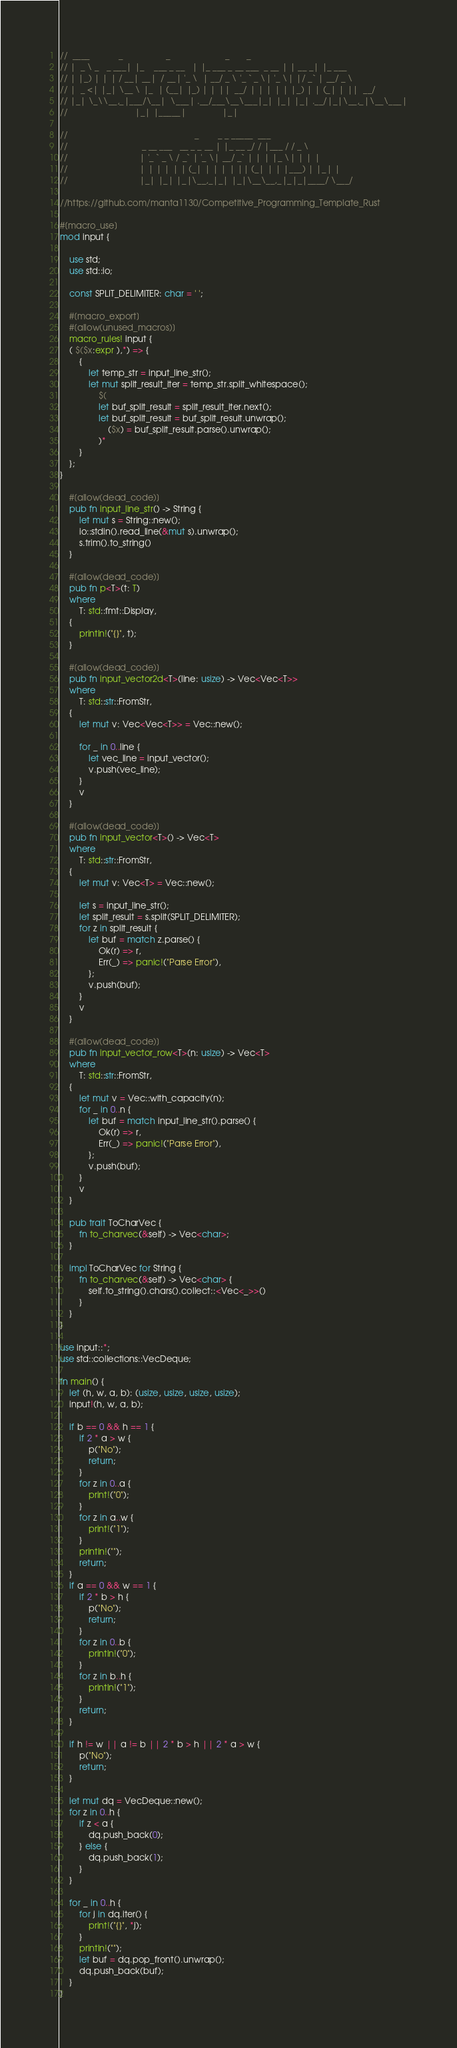<code> <loc_0><loc_0><loc_500><loc_500><_Rust_>//  ____            _                  _                       _       _
// |  _ \ _   _ ___| |_    ___ _ __   | |_ ___ _ __ ___  _ __ | | __ _| |_ ___
// | |_) | | | / __| __|  / __| '_ \  | __/ _ \ '_ ` _ \| '_ \| |/ _` | __/ _ \
// |  _ <| |_| \__ \ |_  | (__| |_) | | ||  __/ | | | | | |_) | | (_| | ||  __/
// |_| \_\\__,_|___/\__|  \___| .__/___\__\___|_| |_| |_| .__/|_|\__,_|\__\___|
//                            |_| |_____|               |_|

//                                                     _        _ _ _____  ___
//                               _ __ ___   __ _ _ __ | |_ __ _/ / |___ / / _ \
//                              | '_ ` _ \ / _` | '_ \| __/ _` | | | |_ \| | | |
//                              | | | | | | (_| | | | | || (_| | | |___) | |_| |
//                              |_| |_| |_|\__,_|_| |_|\__\__,_|_|_|____/ \___/

//https://github.com/manta1130/Competitive_Programming_Template_Rust

#[macro_use]
mod input {

    use std;
    use std::io;

    const SPLIT_DELIMITER: char = ' ';

    #[macro_export]
    #[allow(unused_macros)]
    macro_rules! input {
    ( $($x:expr ),*) => {
        {
            let temp_str = input_line_str();
            let mut split_result_iter = temp_str.split_whitespace();
                $(
                let buf_split_result = split_result_iter.next();
                let buf_split_result = buf_split_result.unwrap();
                    ($x) = buf_split_result.parse().unwrap();
                )*
        }
    };
}

    #[allow(dead_code)]
    pub fn input_line_str() -> String {
        let mut s = String::new();
        io::stdin().read_line(&mut s).unwrap();
        s.trim().to_string()
    }

    #[allow(dead_code)]
    pub fn p<T>(t: T)
    where
        T: std::fmt::Display,
    {
        println!("{}", t);
    }

    #[allow(dead_code)]
    pub fn input_vector2d<T>(line: usize) -> Vec<Vec<T>>
    where
        T: std::str::FromStr,
    {
        let mut v: Vec<Vec<T>> = Vec::new();

        for _ in 0..line {
            let vec_line = input_vector();
            v.push(vec_line);
        }
        v
    }

    #[allow(dead_code)]
    pub fn input_vector<T>() -> Vec<T>
    where
        T: std::str::FromStr,
    {
        let mut v: Vec<T> = Vec::new();

        let s = input_line_str();
        let split_result = s.split(SPLIT_DELIMITER);
        for z in split_result {
            let buf = match z.parse() {
                Ok(r) => r,
                Err(_) => panic!("Parse Error"),
            };
            v.push(buf);
        }
        v
    }

    #[allow(dead_code)]
    pub fn input_vector_row<T>(n: usize) -> Vec<T>
    where
        T: std::str::FromStr,
    {
        let mut v = Vec::with_capacity(n);
        for _ in 0..n {
            let buf = match input_line_str().parse() {
                Ok(r) => r,
                Err(_) => panic!("Parse Error"),
            };
            v.push(buf);
        }
        v
    }

    pub trait ToCharVec {
        fn to_charvec(&self) -> Vec<char>;
    }

    impl ToCharVec for String {
        fn to_charvec(&self) -> Vec<char> {
            self.to_string().chars().collect::<Vec<_>>()
        }
    }
}

use input::*;
use std::collections::VecDeque;

fn main() {
    let (h, w, a, b): (usize, usize, usize, usize);
    input!(h, w, a, b);

    if b == 0 && h == 1 {
        if 2 * a > w {
            p("No");
            return;
        }
        for z in 0..a {
            print!("0");
        }
        for z in a..w {
            print!("1");
        }
        println!("");
        return;
    }
    if a == 0 && w == 1 {
        if 2 * b > h {
            p("No");
            return;
        }
        for z in 0..b {
            println!("0");
        }
        for z in b..h {
            println!("1");
        }
        return;
    }

    if h != w || a != b || 2 * b > h || 2 * a > w {
        p("No");
        return;
    }

    let mut dq = VecDeque::new();
    for z in 0..h {
        if z < a {
            dq.push_back(0);
        } else {
            dq.push_back(1);
        }
    }

    for _ in 0..h {
        for j in dq.iter() {
            print!("{}", *j);
        }
        println!("");
        let buf = dq.pop_front().unwrap();
        dq.push_back(buf);
    }
}</code> 